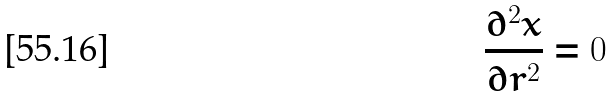Convert formula to latex. <formula><loc_0><loc_0><loc_500><loc_500>\frac { \partial ^ { 2 } x } { \partial r ^ { 2 } } = 0</formula> 